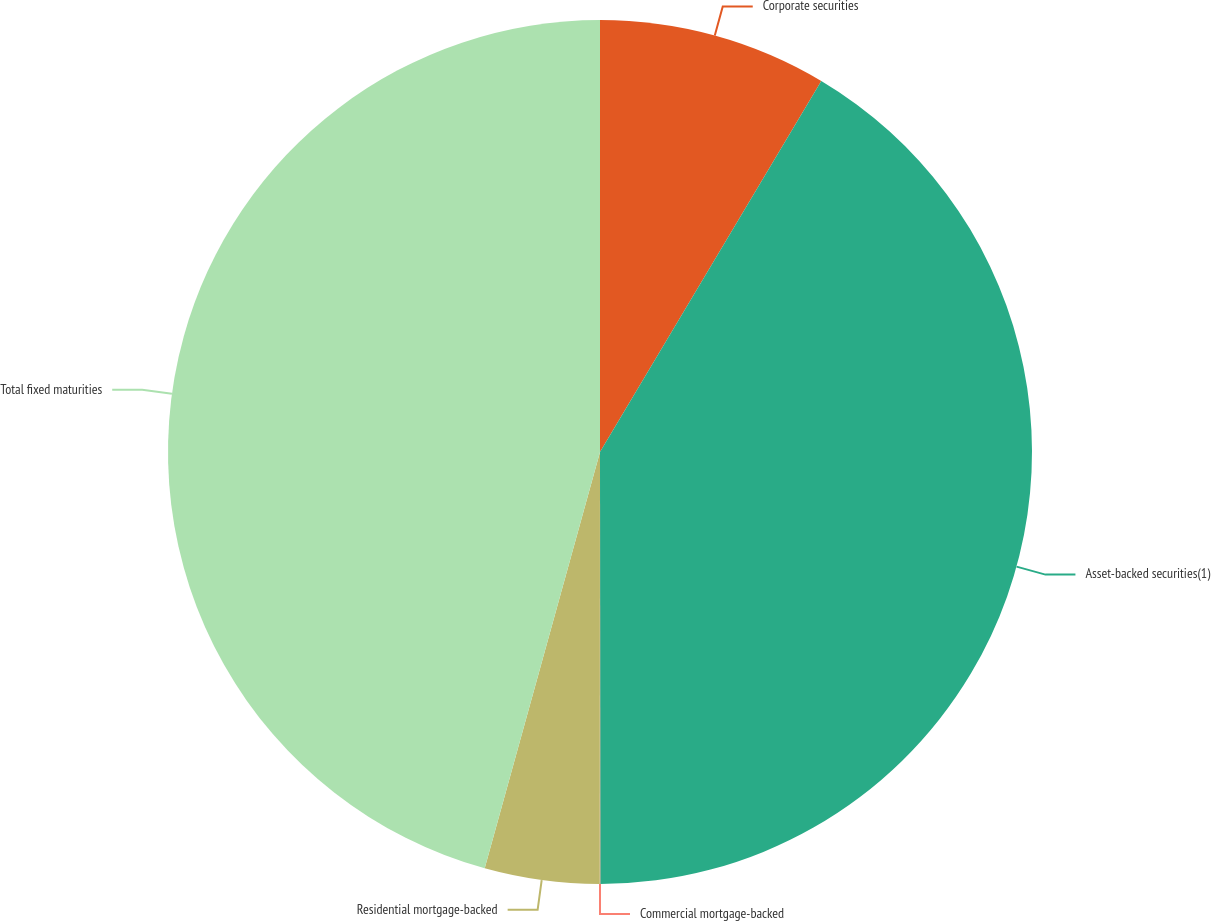Convert chart to OTSL. <chart><loc_0><loc_0><loc_500><loc_500><pie_chart><fcel>Corporate securities<fcel>Asset-backed securities(1)<fcel>Commercial mortgage-backed<fcel>Residential mortgage-backed<fcel>Total fixed maturities<nl><fcel>8.56%<fcel>41.43%<fcel>0.02%<fcel>4.29%<fcel>45.7%<nl></chart> 